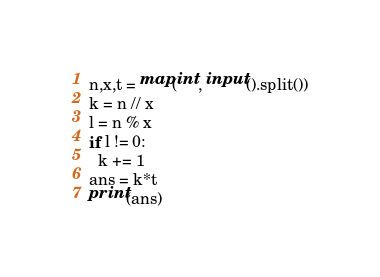Convert code to text. <code><loc_0><loc_0><loc_500><loc_500><_Python_>n,x,t = map(int, input().split())
k = n // x
l = n % x
if l != 0:
  k += 1
ans = k*t
print(ans)</code> 